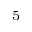<formula> <loc_0><loc_0><loc_500><loc_500>^ { 5 }</formula> 